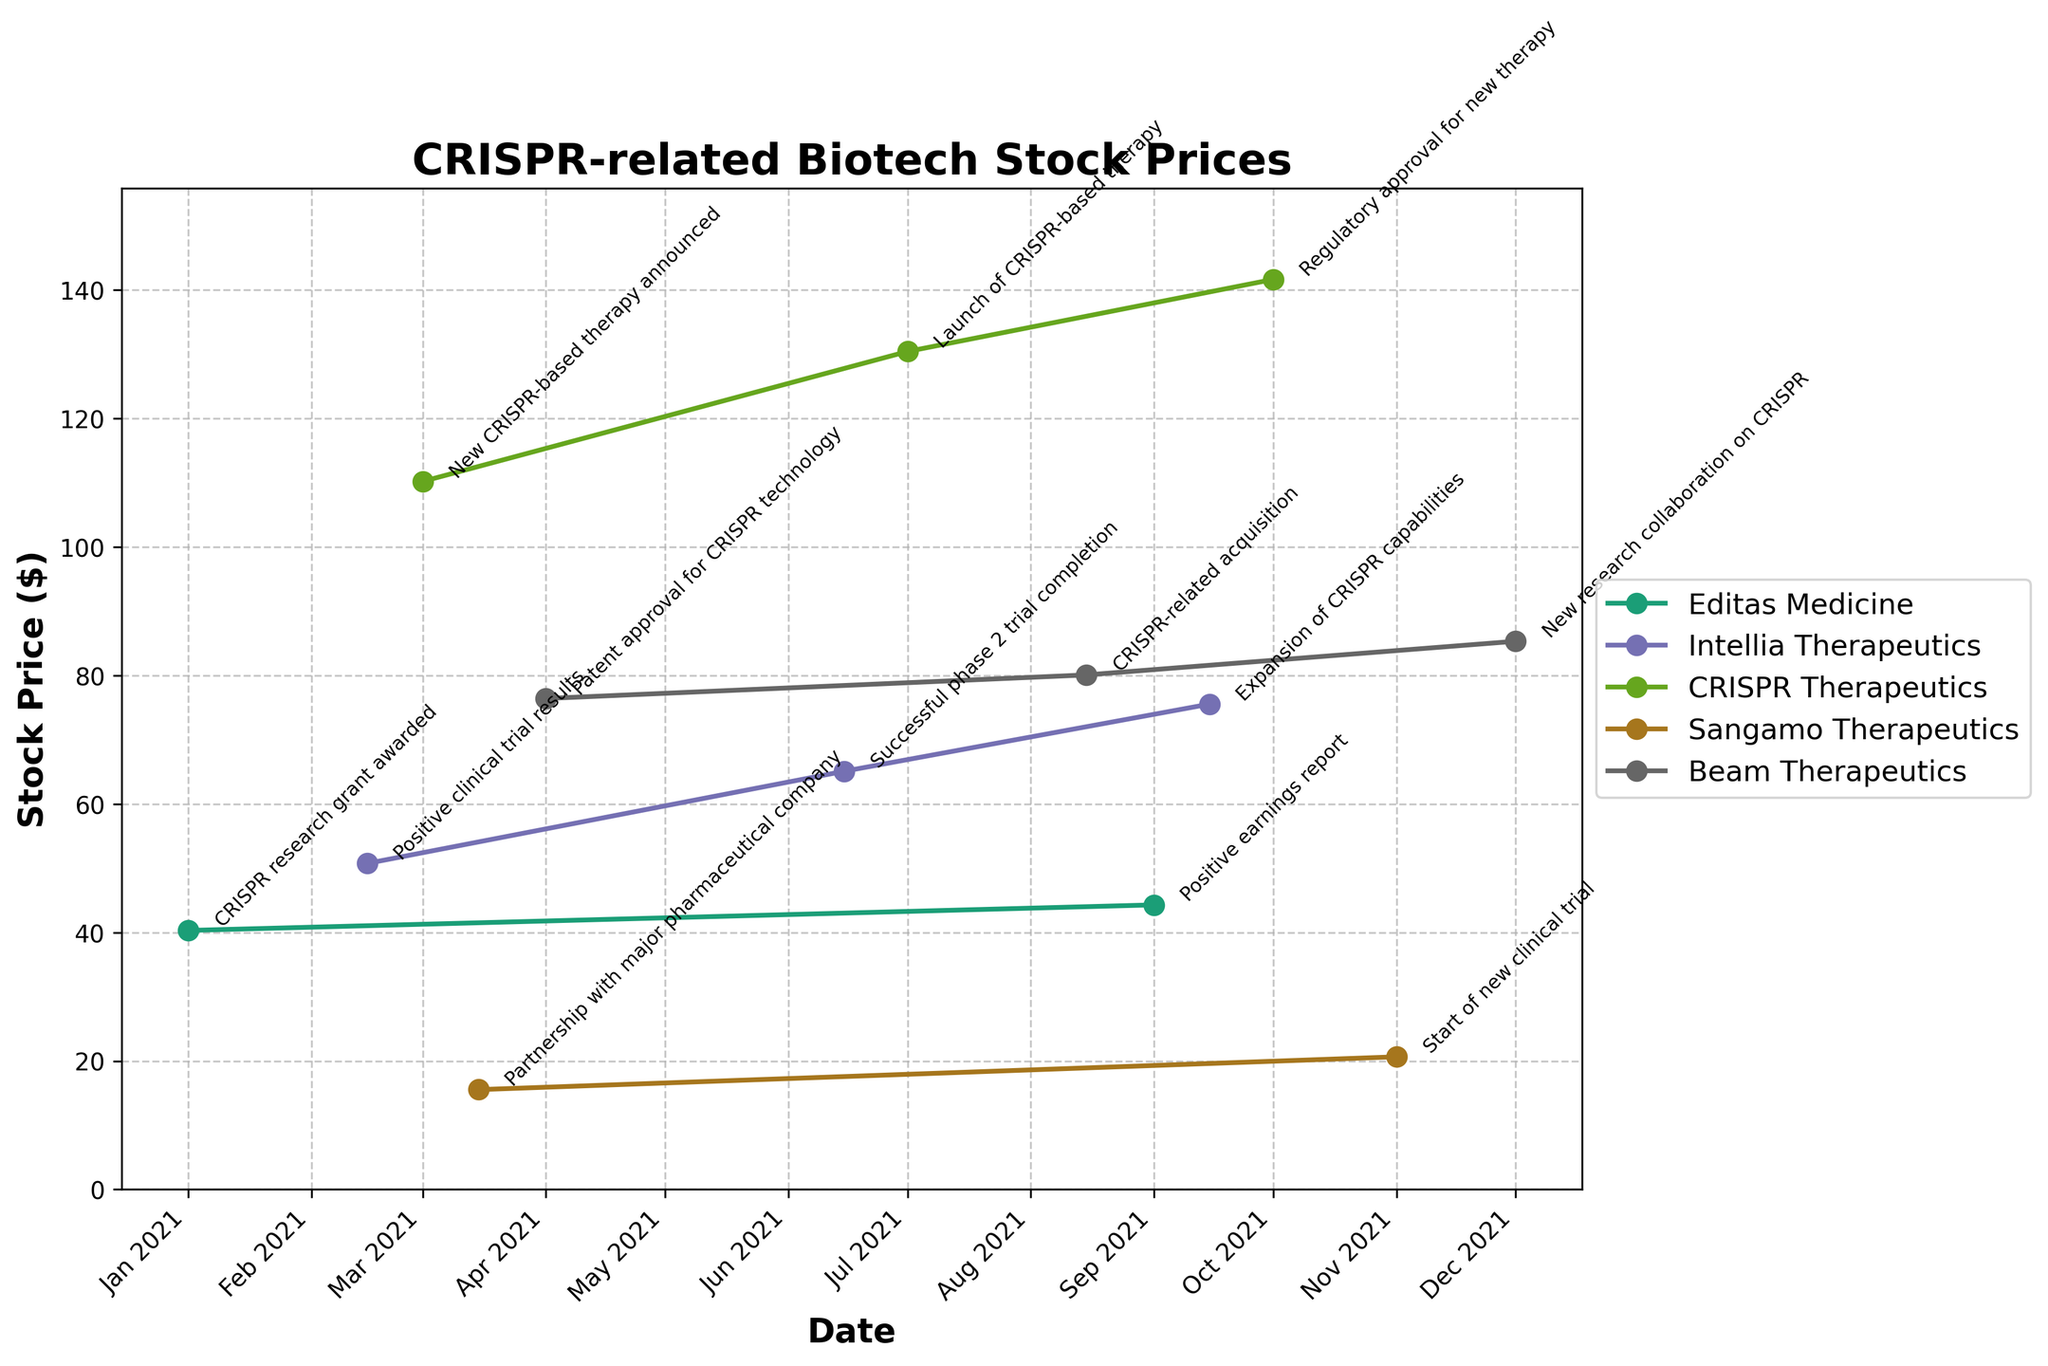What's the title of the figure? The title is prominently displayed at the top of the figure. It reads "CRISPR-related Biotech Stock Prices".
Answer: CRISPR-related Biotech Stock Prices How many companies are represented in the figure? The legend of the graph lists all the companies included in the plot. There are five companies mentioned: Editas Medicine, Intellia Therapeutics, CRISPR Therapeutics, Sangamo Therapeutics, and Beam Therapeutics.
Answer: Five Which company had the highest stock price and when? By following the trend lines and stock prices, CRISPR Therapeutics reached the highest price at $141.67 on October 1, 2021.
Answer: CRISPR Therapeutics, October 1, 2021 What event on March 1, 2021, led to an increase in a company's stock price? Referring to the annotations on the plot, the event on March 1, 2021, was the announcement of a new CRISPR-based therapy by CRISPR Therapeutics.
Answer: New CRISPR-based therapy announced Compare the stock price trends of Intellia Therapeutics and Beam Therapeutics over the year. Who ended the year higher? By visually inspecting the trend lines of both companies, Intellia Therapeutics started higher than Beam Therapeutics but Beam Therapeutics ended the year higher with $85.34 compared to Intellia Therapeutics at $75.56.
Answer: Beam Therapeutics Which event corresponds to the largest single-day stock price increase and for which company? The largest single increase is seen on March 1, 2021, for CRISPR Therapeutics from $110.22 to a high on October 1, 2021. This corresponds with the new CRISPR-based therapy announced.
Answer: CRISPR Therapeutics, New CRISPR-based therapy announced What pattern is observed in the stock price of Beam Therapeutics from April 1, 2021, to December 1, 2021? Observing the stock price progression of Beam Therapeutics shows a general upward trend from $76.43 on April 1 to $85.34 on December 1, indicating a consistent increase with minor fluctuations.
Answer: Upward trend What is the average stock price of Sangamo Therapeutics for the recorded dates in the plot? Sangamo Therapeutics has data points with stock prices of $15.54 and $20.65. The average is calculated by summing these prices and dividing by the number of data points: (15.54 + 20.65) / 2 = 18.10.
Answer: 18.10 Which company experienced a stock price increase due to a patent approval, and what was the date of this event? As indicated by the annotations, Beam Therapeutics experienced a stock price increase on April 1, 2021, due to patent approval for CRISPR technology.
Answer: Beam Therapeutics, April 1, 2021 